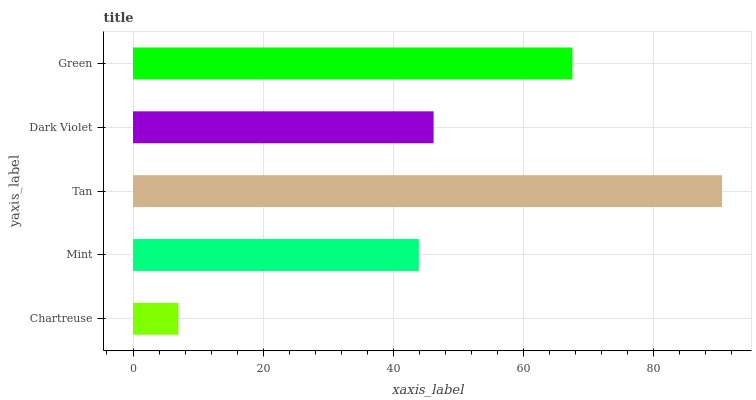Is Chartreuse the minimum?
Answer yes or no. Yes. Is Tan the maximum?
Answer yes or no. Yes. Is Mint the minimum?
Answer yes or no. No. Is Mint the maximum?
Answer yes or no. No. Is Mint greater than Chartreuse?
Answer yes or no. Yes. Is Chartreuse less than Mint?
Answer yes or no. Yes. Is Chartreuse greater than Mint?
Answer yes or no. No. Is Mint less than Chartreuse?
Answer yes or no. No. Is Dark Violet the high median?
Answer yes or no. Yes. Is Dark Violet the low median?
Answer yes or no. Yes. Is Green the high median?
Answer yes or no. No. Is Tan the low median?
Answer yes or no. No. 